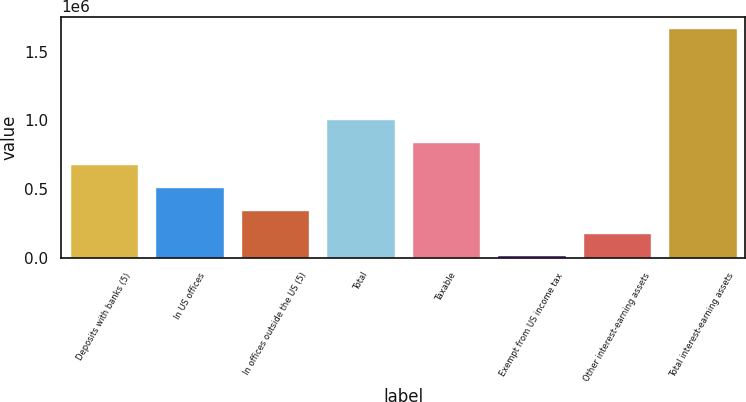Convert chart to OTSL. <chart><loc_0><loc_0><loc_500><loc_500><bar_chart><fcel>Deposits with banks (5)<fcel>In US offices<fcel>In offices outside the US (5)<fcel>Total<fcel>Taxable<fcel>Exempt from US income tax<fcel>Other interest-earning assets<fcel>Total interest-earning assets<nl><fcel>679604<fcel>514241<fcel>348878<fcel>1.01033e+06<fcel>844966<fcel>18152<fcel>183515<fcel>1.67178e+06<nl></chart> 